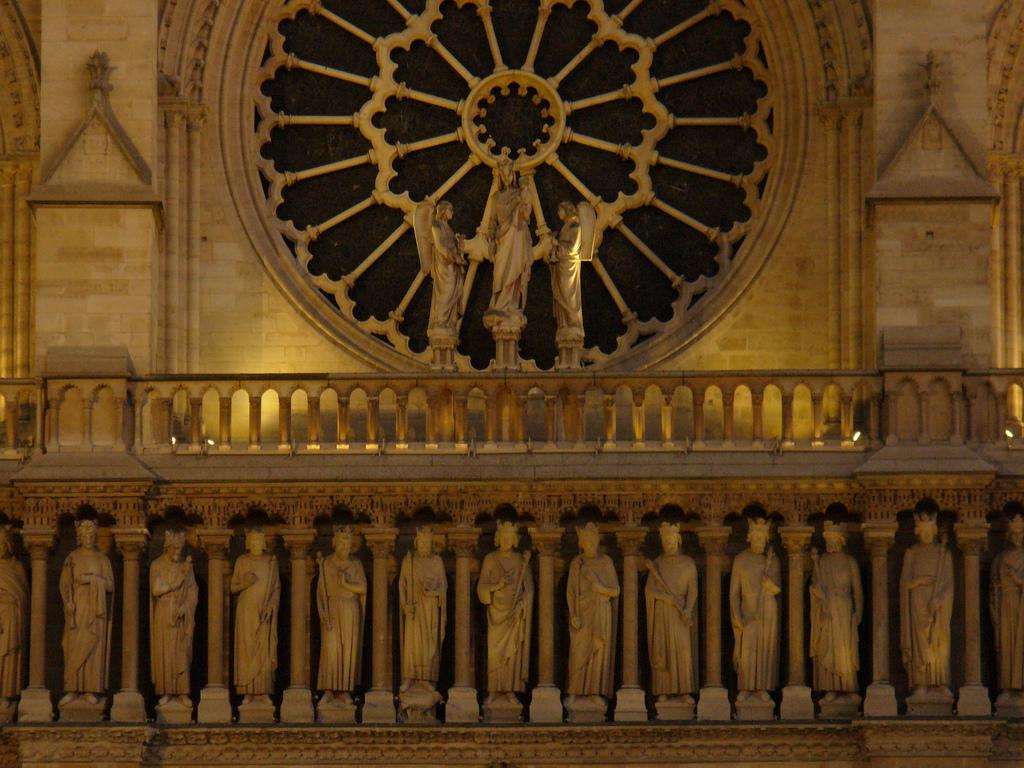What type of objects are depicted in the image? There are sculptures of people in the image. Are there any other elements present in the image besides the sculptures? Yes, there are lights in the image. What type of prose can be heard being recited by the sculptures in the image? There is no prose being recited by the sculptures in the image, as they are inanimate objects and cannot speak or recite anything. 